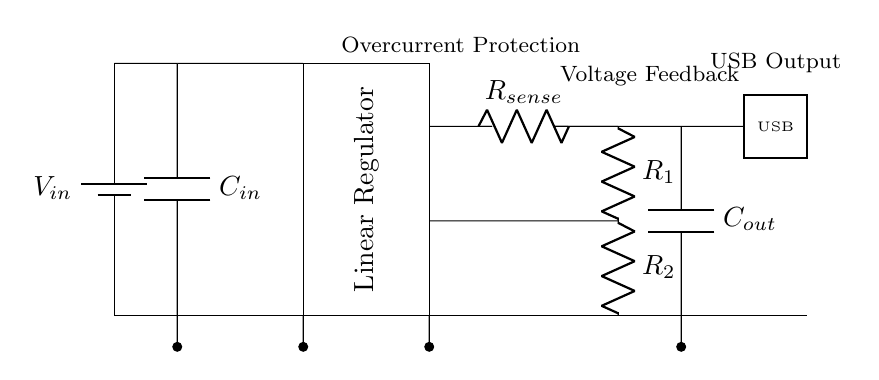What is the input voltage labeled in the circuit? The input voltage is labeled as V in the circuit diagram, located next to the battery symbol at the top left of the diagram.
Answer: V in What type of voltage regulator is used in this circuit? The circuit diagram indicates a "Linear Regulator" by labeling it within a rectangle located in the center of the diagram.
Answer: Linear Regulator What is the purpose of the resistor labeled R sense? R sense acts as a current sensing resistor to monitor the output current for overcurrent protection, as indicated by the label next to it.
Answer: Overcurrent Protection How many capacitors are present in this circuit? There are two capacitors in the circuit, denoted as C in and C out, which are located at the input and output, respectively.
Answer: Two What components are used for feedback in the circuit? Feedback components include resistors R one and R two, which create a voltage divider to provide feedback for the linear regulator to maintain stable output, positioned at the output side of the regulator.
Answer: R one and R two What is the connection type for the USB output? The USB output connection is represented as a rectangular box labeled USB, indicating that it provides a standardized interface for power delivery.
Answer: Rectangle 